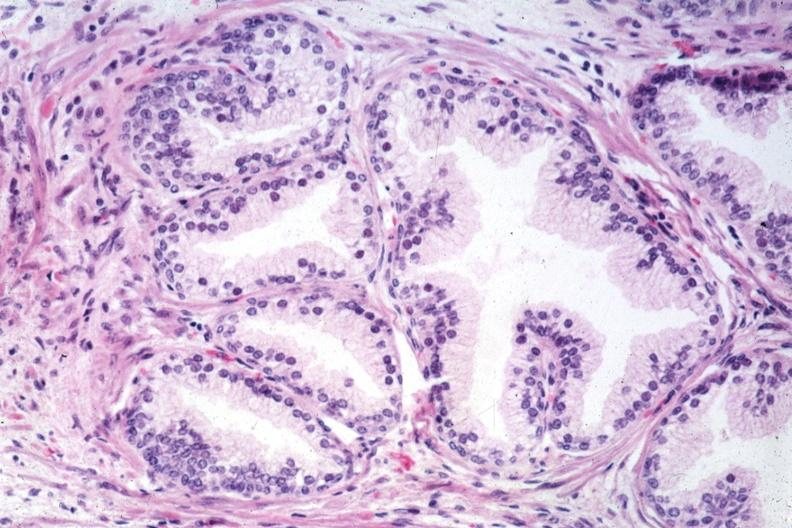does this image show very good example of normal prostate gland?
Answer the question using a single word or phrase. Yes 